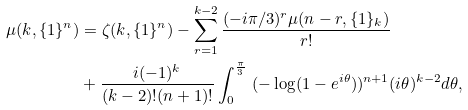Convert formula to latex. <formula><loc_0><loc_0><loc_500><loc_500>\mu ( k , \{ 1 \} ^ { n } ) & = \zeta ( k , \{ 1 \} ^ { n } ) - \sum _ { r = 1 } ^ { k - 2 } \frac { ( - i \pi / 3 ) ^ { r } \mu ( n - r , \{ 1 \} _ { k } ) } { r ! } \\ & + \frac { i ( - 1 ) ^ { k } } { ( k - 2 ) ! ( n + 1 ) ! } \int _ { 0 } ^ { \frac { \pi } { 3 } } \ ( - \log ( 1 - e ^ { i \theta } ) ) ^ { n + 1 } ( i \theta ) ^ { k - 2 } d \theta ,</formula> 